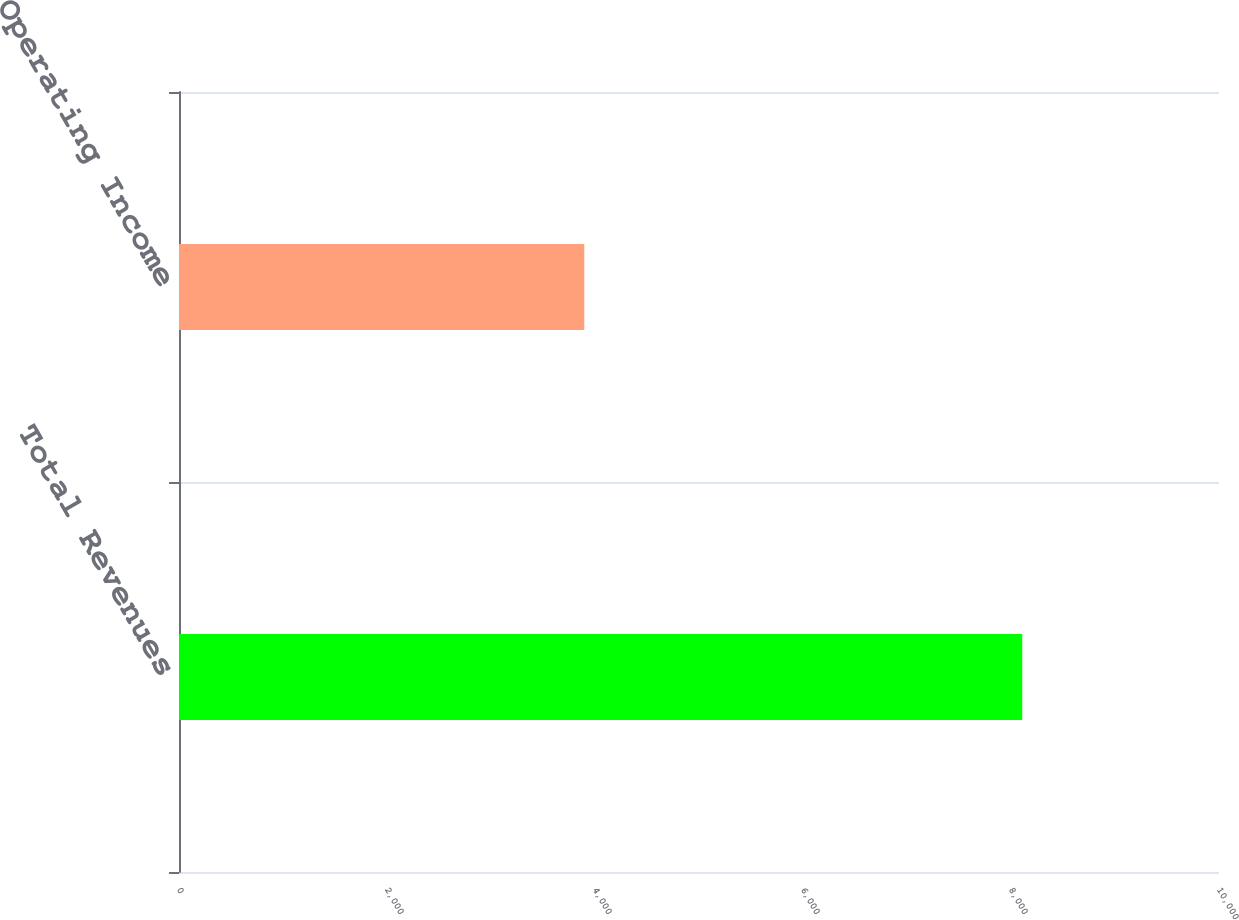Convert chart to OTSL. <chart><loc_0><loc_0><loc_500><loc_500><bar_chart><fcel>Total Revenues<fcel>Operating Income<nl><fcel>8108<fcel>3897<nl></chart> 